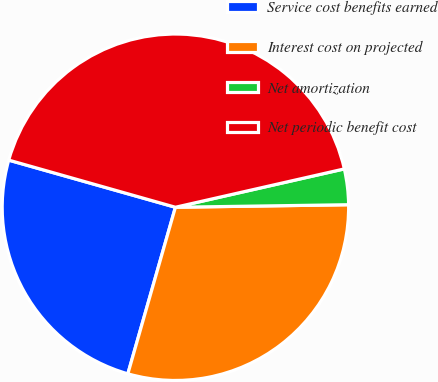Convert chart. <chart><loc_0><loc_0><loc_500><loc_500><pie_chart><fcel>Service cost benefits earned<fcel>Interest cost on projected<fcel>Net amortization<fcel>Net periodic benefit cost<nl><fcel>24.96%<fcel>29.66%<fcel>3.32%<fcel>42.06%<nl></chart> 